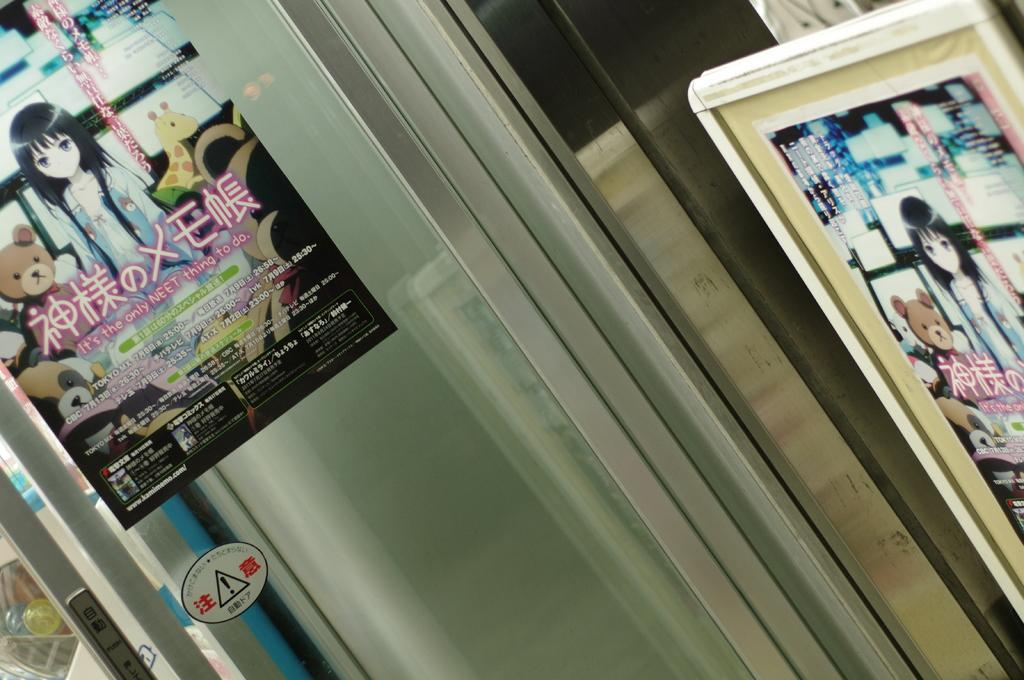What is located on the glass wall in the foreground of the image? There are posters on a glass wall in the foreground. Can you describe anything on the right side of the image? There is a frame on the right side of the image. What does the ladybug taste like in the image? There is no ladybug present in the image, so it is not possible to determine its taste. 